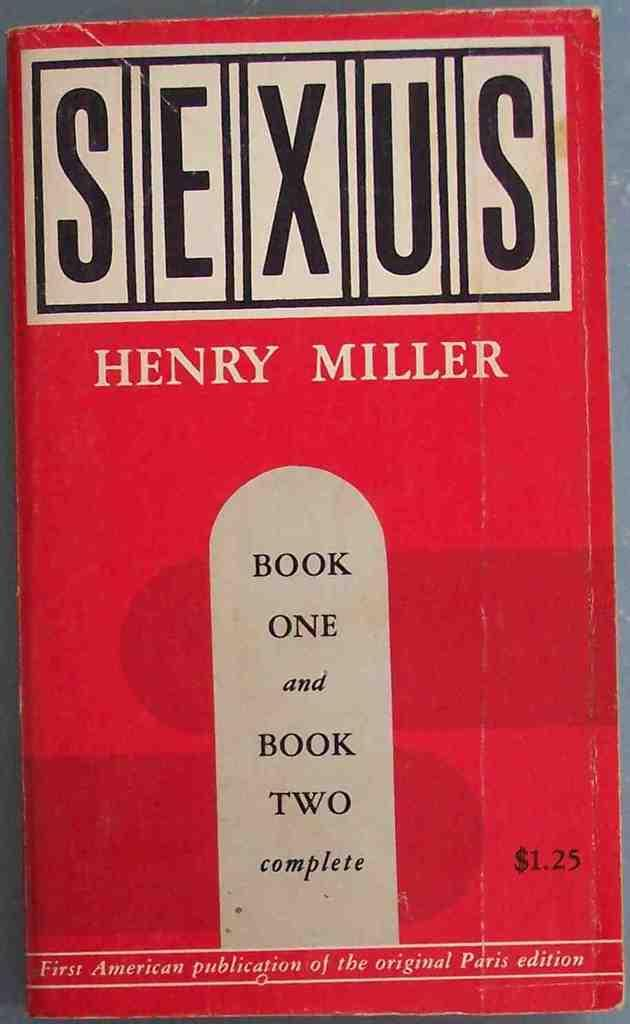<image>
Render a clear and concise summary of the photo. book one and book two complete of sexus by henry miller 